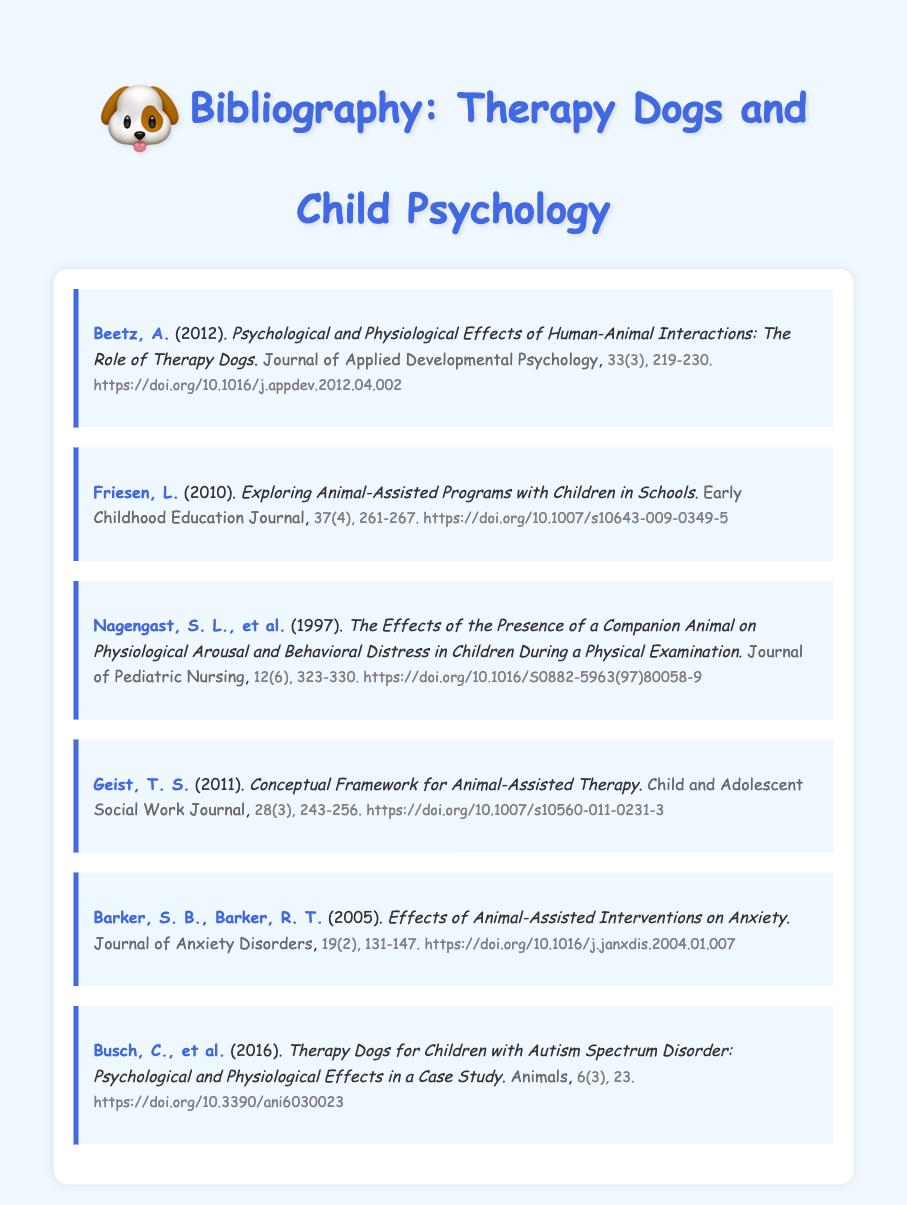What is the title of Beetz's paper? The title of Beetz's paper is given in the entry about her work, which discusses the psychological and physiological effects of human-animal interactions.
Answer: Psychological and Physiological Effects of Human-Animal Interactions: The Role of Therapy Dogs What year was Friesen's study published? The year of publication for Friesen's study is located in the entry, showing the year specifically as part of the reference details.
Answer: 2010 What journal published Barker and Barker's article? The journal that published Barker and Barker's article is identified in the entry, indicating where their research on anxiety can be found.
Answer: Journal of Anxiety Disorders Who are the authors of the entry regarding therapy dogs for children with autism? The authors' names are listed in the corresponding entry related to the psychological and physiological effects of therapy dogs on children with autism.
Answer: Busch, C., et al How many authors contributed to Nagengast's study? The number of authors is deduced from the entry showing their names at the beginning of the reference for the study on companion animals.
Answer: 3 In which volume of the "Child and Adolescent Social Work Journal" is Geist’s paper published? The volume number is indicated in the entry for Geist’s paper and is relevant to locating the article in the journal.
Answer: 28 What are the page numbers for Beetz's article? The page numbers are mentioned in the entry for Beetz's article, specifying where it can be found in the journal.
Answer: 219-230 Which year did Barker and Barker conduct their research? The year of the research by Barker and Barker is specified in their entry and is used to contextualize their findings within the broader timeline.
Answer: 2005 